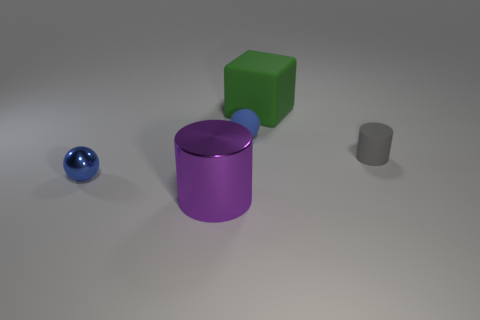If these objects were used in a game, what could the rules be? One possible game could involve stacking the differently shaped objects in a specific order or within a limited time frame to build a stable structure. Another might be a sorting game, where players group objects by color or shape. 